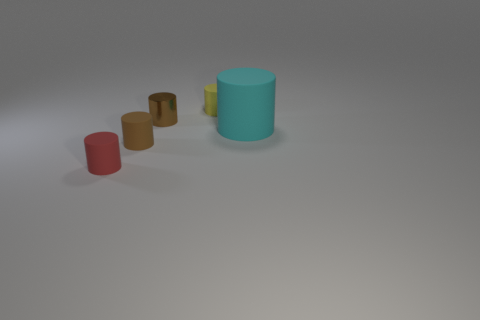There is a red object that is made of the same material as the large cylinder; what shape is it?
Give a very brief answer. Cylinder. Is the shape of the small brown object in front of the large rubber thing the same as the yellow rubber thing behind the brown rubber thing?
Your answer should be compact. Yes. Is the number of small brown metallic things on the right side of the yellow rubber thing less than the number of small matte things that are left of the cyan matte cylinder?
Your answer should be compact. Yes. There is a rubber thing that is the same color as the small metallic cylinder; what shape is it?
Make the answer very short. Cylinder. How many brown matte cylinders have the same size as the yellow rubber cylinder?
Offer a terse response. 1. Is the tiny cylinder behind the shiny thing made of the same material as the cyan object?
Keep it short and to the point. Yes. Are there any big cyan spheres?
Offer a very short reply. No. There is a red cylinder that is made of the same material as the big thing; what is its size?
Your answer should be compact. Small. Is there another thing that has the same color as the metal object?
Provide a succinct answer. Yes. The thing that is the same color as the metallic cylinder is what size?
Ensure brevity in your answer.  Small. 